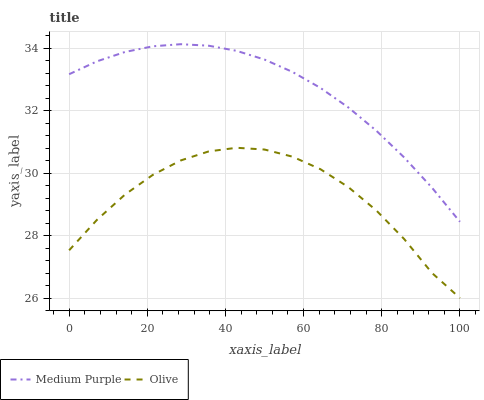Does Olive have the minimum area under the curve?
Answer yes or no. Yes. Does Medium Purple have the maximum area under the curve?
Answer yes or no. Yes. Does Olive have the maximum area under the curve?
Answer yes or no. No. Is Medium Purple the smoothest?
Answer yes or no. Yes. Is Olive the roughest?
Answer yes or no. Yes. Is Olive the smoothest?
Answer yes or no. No. Does Olive have the lowest value?
Answer yes or no. Yes. Does Medium Purple have the highest value?
Answer yes or no. Yes. Does Olive have the highest value?
Answer yes or no. No. Is Olive less than Medium Purple?
Answer yes or no. Yes. Is Medium Purple greater than Olive?
Answer yes or no. Yes. Does Olive intersect Medium Purple?
Answer yes or no. No. 